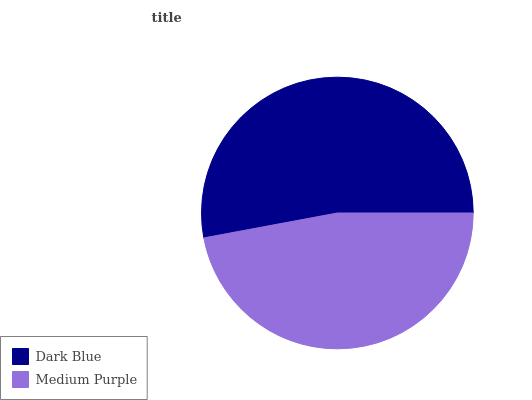Is Medium Purple the minimum?
Answer yes or no. Yes. Is Dark Blue the maximum?
Answer yes or no. Yes. Is Medium Purple the maximum?
Answer yes or no. No. Is Dark Blue greater than Medium Purple?
Answer yes or no. Yes. Is Medium Purple less than Dark Blue?
Answer yes or no. Yes. Is Medium Purple greater than Dark Blue?
Answer yes or no. No. Is Dark Blue less than Medium Purple?
Answer yes or no. No. Is Dark Blue the high median?
Answer yes or no. Yes. Is Medium Purple the low median?
Answer yes or no. Yes. Is Medium Purple the high median?
Answer yes or no. No. Is Dark Blue the low median?
Answer yes or no. No. 